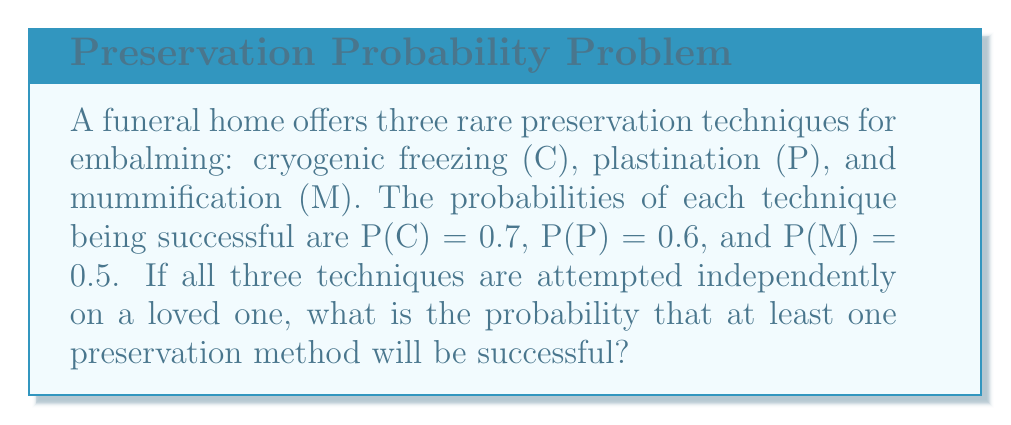Teach me how to tackle this problem. To solve this problem, we'll use the concept of set operations and the principle of inclusion-exclusion.

Let's define the events:
C: Cryogenic freezing is successful
P: Plastination is successful
M: Mummification is successful

We want to find P(C ∪ P ∪ M), which is the probability that at least one method is successful.

Using the principle of inclusion-exclusion for three sets:

$$P(C ∪ P ∪ M) = P(C) + P(P) + P(M) - P(C ∩ P) - P(C ∩ M) - P(P ∩ M) + P(C ∩ P ∩ M)$$

Given:
P(C) = 0.7
P(P) = 0.6
P(M) = 0.5

Since the techniques are attempted independently, we can multiply probabilities for intersections:

P(C ∩ P) = P(C) × P(P) = 0.7 × 0.6 = 0.42
P(C ∩ M) = P(C) × P(M) = 0.7 × 0.5 = 0.35
P(P ∩ M) = P(P) × P(M) = 0.6 × 0.5 = 0.30
P(C ∩ P ∩ M) = P(C) × P(P) × P(M) = 0.7 × 0.6 × 0.5 = 0.21

Now, let's substitute these values into our equation:

$$\begin{align*}
P(C ∪ P ∪ M) &= 0.7 + 0.6 + 0.5 - 0.42 - 0.35 - 0.30 + 0.21 \\
&= 1.8 - 1.07 + 0.21 \\
&= 0.94
\end{align*}$$

Therefore, the probability that at least one preservation method will be successful is 0.94 or 94%.
Answer: 0.94 or 94% 